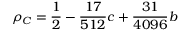<formula> <loc_0><loc_0><loc_500><loc_500>\rho _ { C } = \frac { 1 } { 2 } - \frac { 1 7 } { 5 1 2 } c + \frac { 3 1 } { 4 0 9 6 } b</formula> 